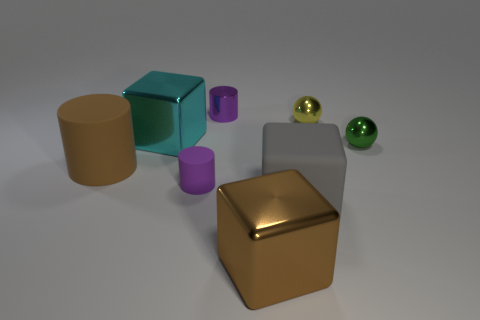What is the shape of the big object that is the same color as the large cylinder?
Provide a succinct answer. Cube. There is a brown object that is in front of the large brown object that is left of the tiny cylinder in front of the small yellow shiny ball; what is its size?
Your response must be concise. Large. There is a tiny yellow thing; does it have the same shape as the purple object that is behind the yellow object?
Make the answer very short. No. The brown cylinder that is made of the same material as the big gray object is what size?
Your answer should be compact. Large. Is there any other thing that has the same color as the big matte cylinder?
Your answer should be very brief. Yes. There is a tiny cylinder in front of the small purple thing behind the big metallic object that is on the left side of the small purple matte object; what is it made of?
Your answer should be very brief. Rubber. What number of matte objects are either brown blocks or yellow balls?
Your answer should be very brief. 0. Is the color of the small shiny cylinder the same as the tiny matte cylinder?
Your answer should be compact. Yes. How many objects are either tiny blue spheres or big rubber objects left of the purple shiny thing?
Make the answer very short. 1. Is the size of the brown object that is to the left of the cyan metal thing the same as the large gray matte object?
Make the answer very short. Yes. 